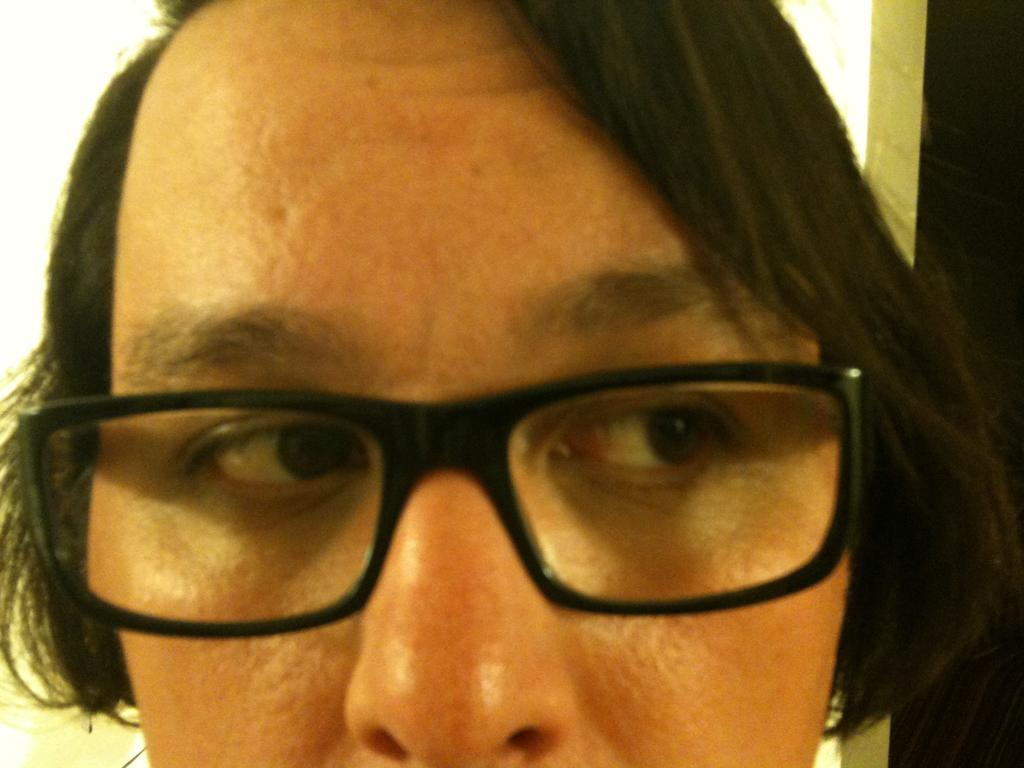Who or what is present in the image? There is a person in the image. What is the person wearing that is noticeable? The person is wearing black color specs. What can be seen in the background of the image? There is a door in the background of the image. Can you see any fangs on the person in the image? There are no fangs visible on the person in the image. What type of iron object is present in the image? There is no iron object present in the image. 